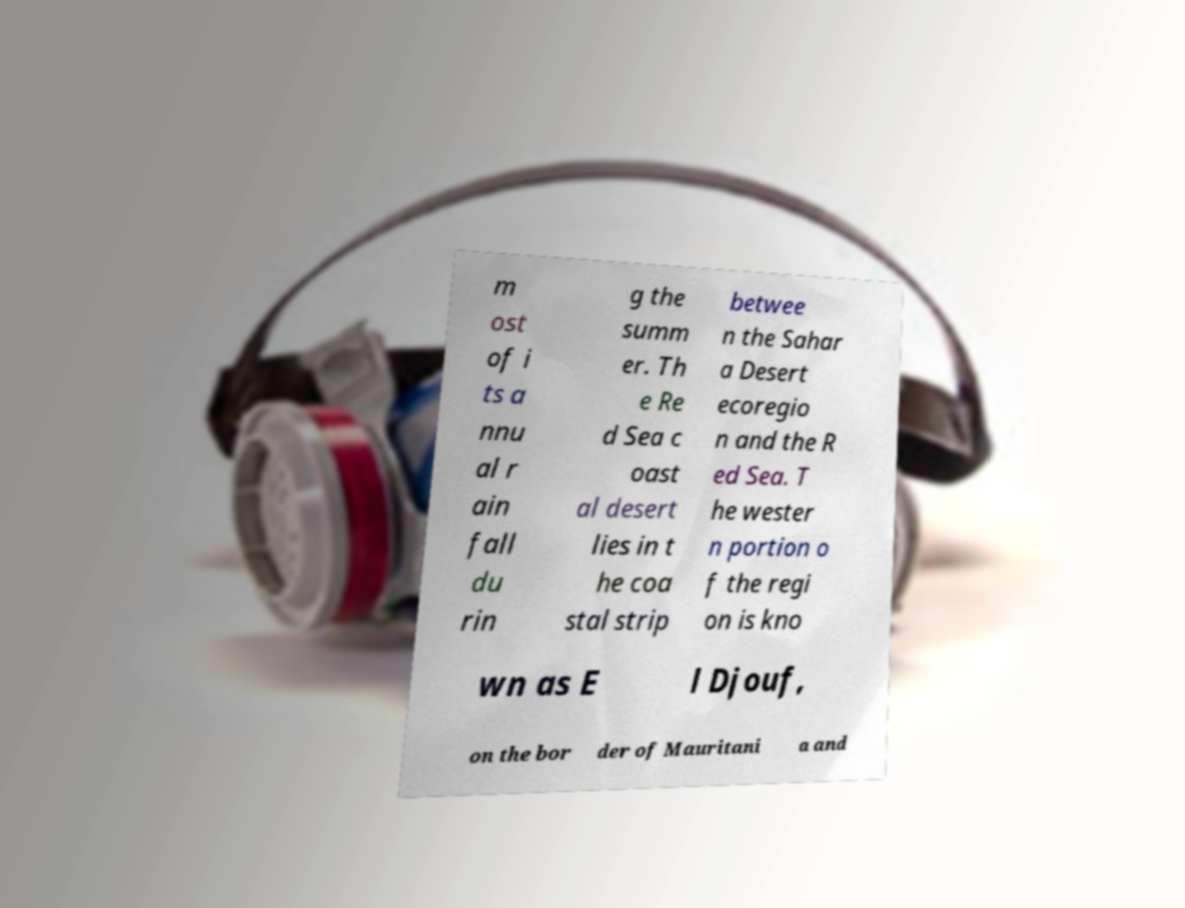There's text embedded in this image that I need extracted. Can you transcribe it verbatim? m ost of i ts a nnu al r ain fall du rin g the summ er. Th e Re d Sea c oast al desert lies in t he coa stal strip betwee n the Sahar a Desert ecoregio n and the R ed Sea. T he wester n portion o f the regi on is kno wn as E l Djouf, on the bor der of Mauritani a and 